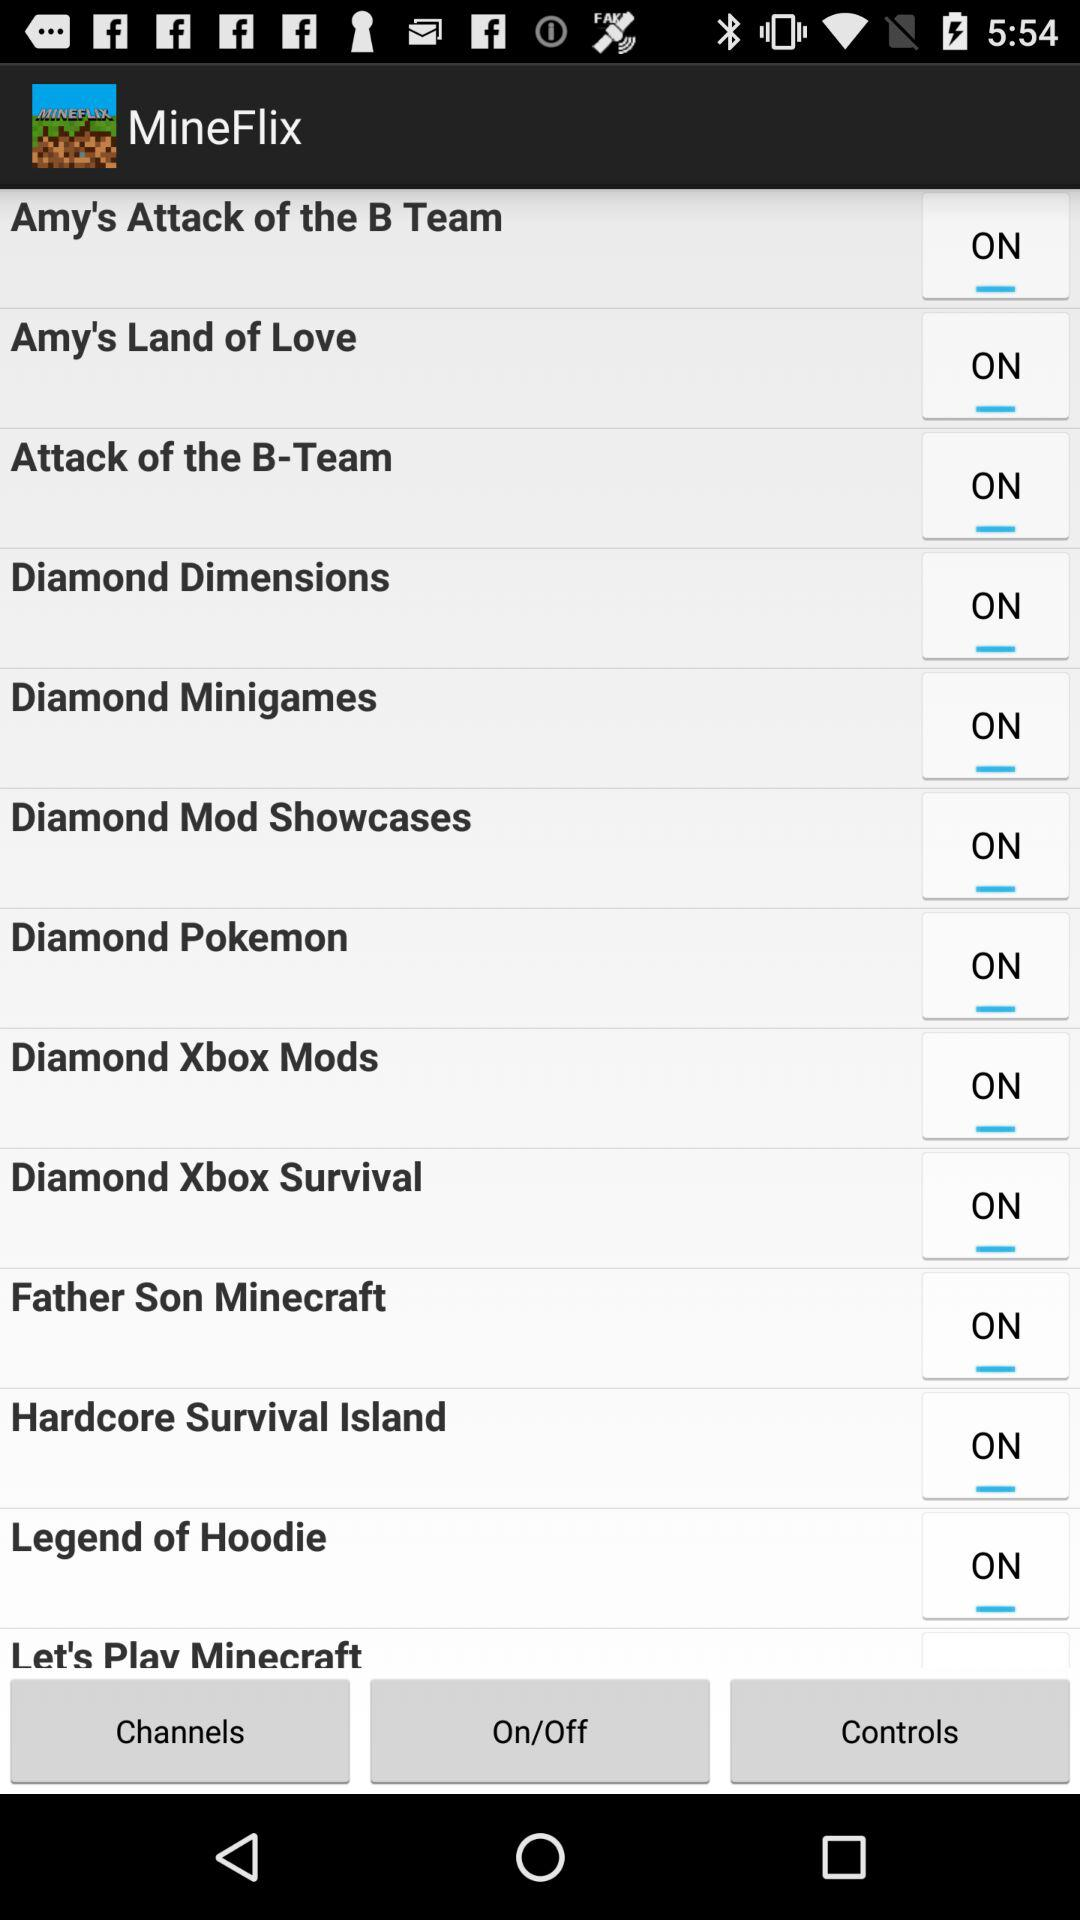What is the status of the "Amy's Land of Love"? The status of the "Amy's Land of Love" is "on". 